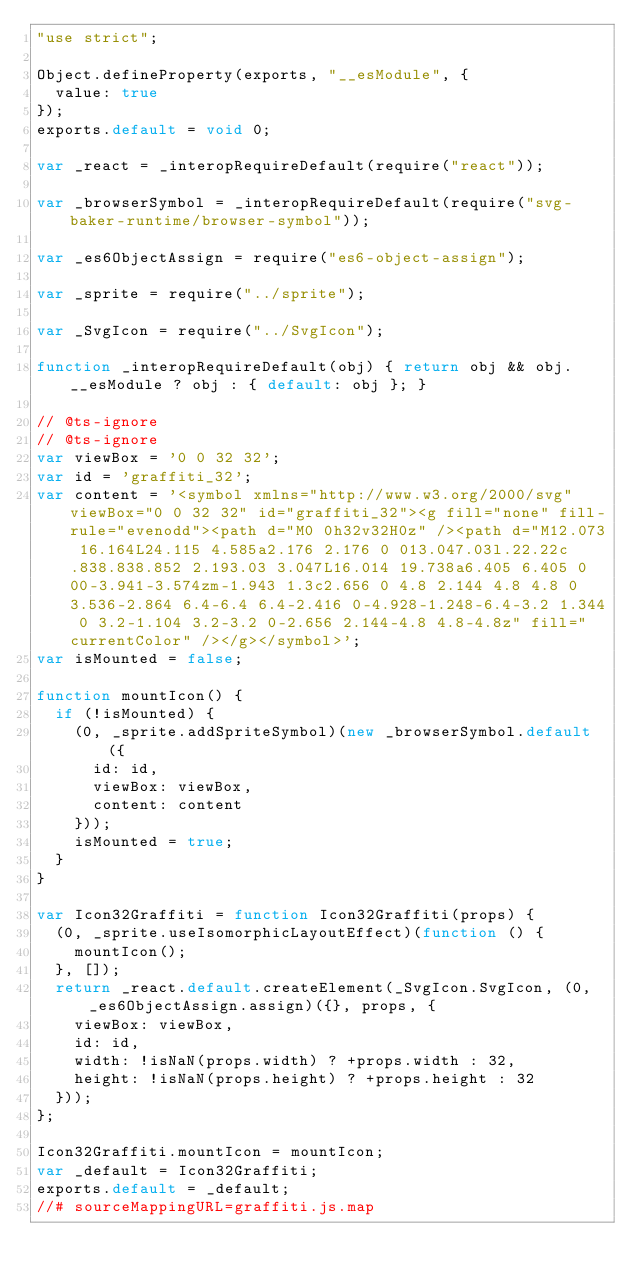<code> <loc_0><loc_0><loc_500><loc_500><_JavaScript_>"use strict";

Object.defineProperty(exports, "__esModule", {
  value: true
});
exports.default = void 0;

var _react = _interopRequireDefault(require("react"));

var _browserSymbol = _interopRequireDefault(require("svg-baker-runtime/browser-symbol"));

var _es6ObjectAssign = require("es6-object-assign");

var _sprite = require("../sprite");

var _SvgIcon = require("../SvgIcon");

function _interopRequireDefault(obj) { return obj && obj.__esModule ? obj : { default: obj }; }

// @ts-ignore
// @ts-ignore
var viewBox = '0 0 32 32';
var id = 'graffiti_32';
var content = '<symbol xmlns="http://www.w3.org/2000/svg" viewBox="0 0 32 32" id="graffiti_32"><g fill="none" fill-rule="evenodd"><path d="M0 0h32v32H0z" /><path d="M12.073 16.164L24.115 4.585a2.176 2.176 0 013.047.03l.22.22c.838.838.852 2.193.03 3.047L16.014 19.738a6.405 6.405 0 00-3.941-3.574zm-1.943 1.3c2.656 0 4.8 2.144 4.8 4.8 0 3.536-2.864 6.4-6.4 6.4-2.416 0-4.928-1.248-6.4-3.2 1.344 0 3.2-1.104 3.2-3.2 0-2.656 2.144-4.8 4.8-4.8z" fill="currentColor" /></g></symbol>';
var isMounted = false;

function mountIcon() {
  if (!isMounted) {
    (0, _sprite.addSpriteSymbol)(new _browserSymbol.default({
      id: id,
      viewBox: viewBox,
      content: content
    }));
    isMounted = true;
  }
}

var Icon32Graffiti = function Icon32Graffiti(props) {
  (0, _sprite.useIsomorphicLayoutEffect)(function () {
    mountIcon();
  }, []);
  return _react.default.createElement(_SvgIcon.SvgIcon, (0, _es6ObjectAssign.assign)({}, props, {
    viewBox: viewBox,
    id: id,
    width: !isNaN(props.width) ? +props.width : 32,
    height: !isNaN(props.height) ? +props.height : 32
  }));
};

Icon32Graffiti.mountIcon = mountIcon;
var _default = Icon32Graffiti;
exports.default = _default;
//# sourceMappingURL=graffiti.js.map</code> 